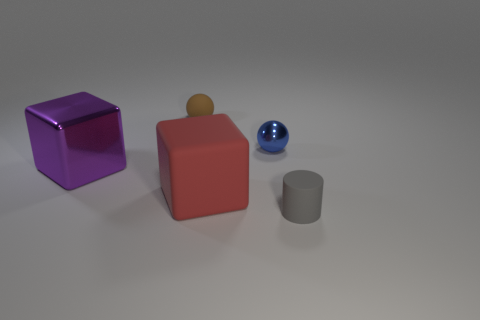The big thing to the right of the large object that is on the left side of the brown rubber object is made of what material?
Give a very brief answer. Rubber. What number of things are either objects on the left side of the cylinder or yellow matte cylinders?
Offer a very short reply. 4. Are there the same number of small blue shiny balls that are on the right side of the metallic sphere and large cubes that are in front of the small matte cylinder?
Ensure brevity in your answer.  Yes. The tiny thing in front of the big cube right of the object on the left side of the brown thing is made of what material?
Offer a very short reply. Rubber. What is the size of the thing that is both behind the matte cube and in front of the blue sphere?
Offer a very short reply. Large. Is the big red rubber object the same shape as the large purple thing?
Your answer should be compact. Yes. The red object that is the same material as the gray thing is what shape?
Your answer should be compact. Cube. What number of tiny things are blue metallic cubes or red cubes?
Your response must be concise. 0. Are there any big things right of the rubber thing behind the purple metallic cube?
Keep it short and to the point. Yes. Are there any small gray rubber things?
Ensure brevity in your answer.  Yes. 